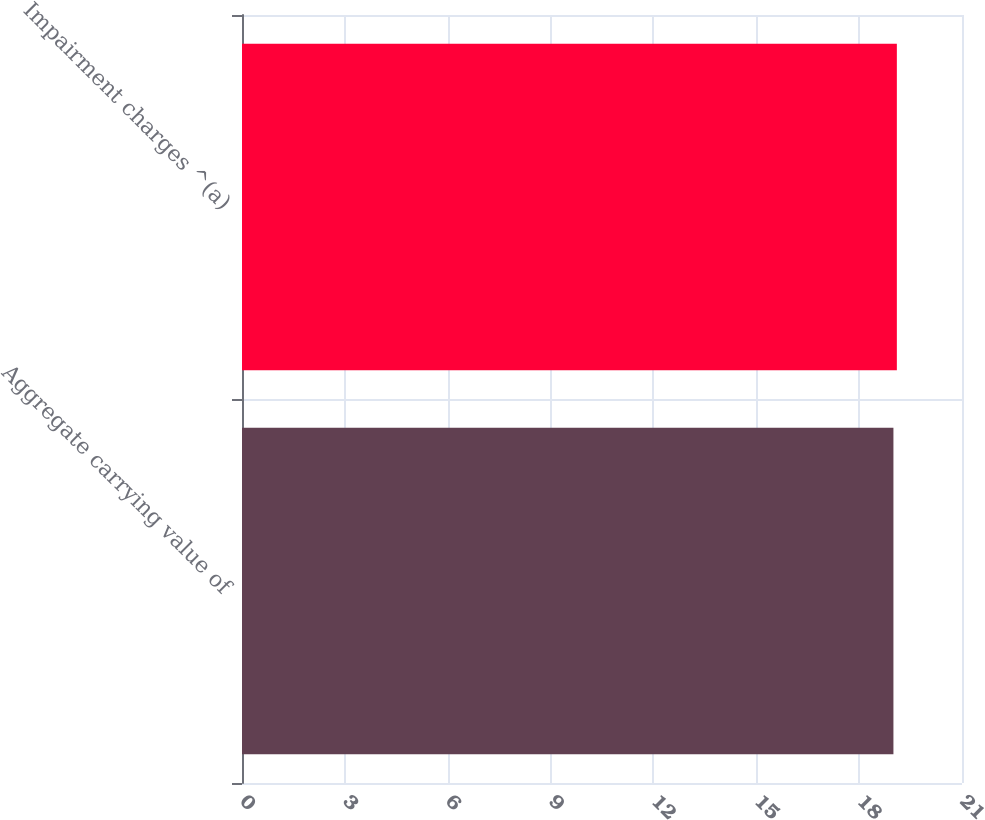<chart> <loc_0><loc_0><loc_500><loc_500><bar_chart><fcel>Aggregate carrying value of<fcel>Impairment charges ^(a)<nl><fcel>19<fcel>19.1<nl></chart> 